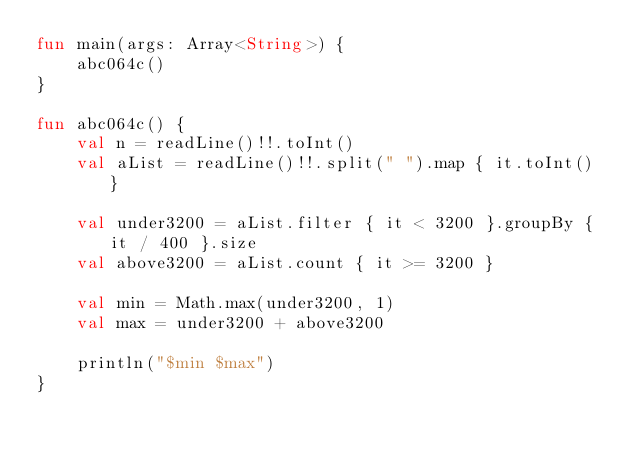<code> <loc_0><loc_0><loc_500><loc_500><_Kotlin_>fun main(args: Array<String>) {
    abc064c()
}

fun abc064c() {
    val n = readLine()!!.toInt()
    val aList = readLine()!!.split(" ").map { it.toInt() }

    val under3200 = aList.filter { it < 3200 }.groupBy { it / 400 }.size
    val above3200 = aList.count { it >= 3200 }

    val min = Math.max(under3200, 1)
    val max = under3200 + above3200

    println("$min $max")
}
</code> 